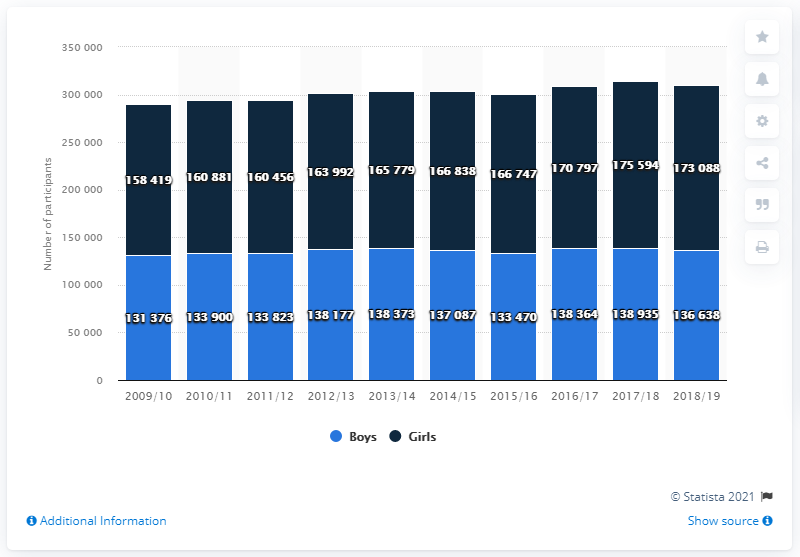Give some essential details in this illustration. In the 2018/19 season, a total of 17,308 girls participated in high school swimming and diving. 